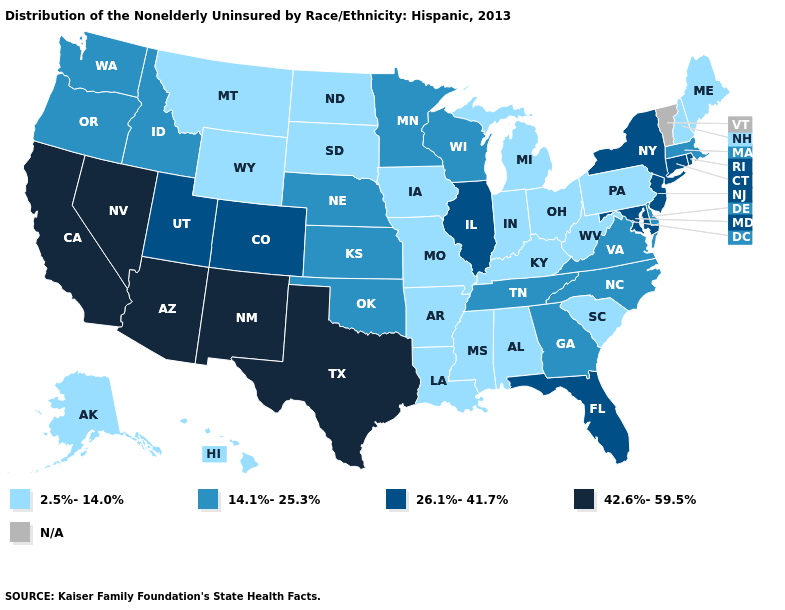What is the highest value in states that border South Dakota?
Concise answer only. 14.1%-25.3%. Does the first symbol in the legend represent the smallest category?
Short answer required. Yes. What is the value of Massachusetts?
Concise answer only. 14.1%-25.3%. Among the states that border Missouri , which have the highest value?
Concise answer only. Illinois. What is the value of Nebraska?
Short answer required. 14.1%-25.3%. Name the states that have a value in the range 14.1%-25.3%?
Quick response, please. Delaware, Georgia, Idaho, Kansas, Massachusetts, Minnesota, Nebraska, North Carolina, Oklahoma, Oregon, Tennessee, Virginia, Washington, Wisconsin. What is the value of Minnesota?
Keep it brief. 14.1%-25.3%. Does Arkansas have the highest value in the South?
Answer briefly. No. Name the states that have a value in the range N/A?
Keep it brief. Vermont. Name the states that have a value in the range 2.5%-14.0%?
Concise answer only. Alabama, Alaska, Arkansas, Hawaii, Indiana, Iowa, Kentucky, Louisiana, Maine, Michigan, Mississippi, Missouri, Montana, New Hampshire, North Dakota, Ohio, Pennsylvania, South Carolina, South Dakota, West Virginia, Wyoming. Among the states that border Vermont , which have the highest value?
Answer briefly. New York. Name the states that have a value in the range 2.5%-14.0%?
Quick response, please. Alabama, Alaska, Arkansas, Hawaii, Indiana, Iowa, Kentucky, Louisiana, Maine, Michigan, Mississippi, Missouri, Montana, New Hampshire, North Dakota, Ohio, Pennsylvania, South Carolina, South Dakota, West Virginia, Wyoming. Which states hav the highest value in the South?
Keep it brief. Texas. Name the states that have a value in the range N/A?
Write a very short answer. Vermont. Which states have the lowest value in the USA?
Short answer required. Alabama, Alaska, Arkansas, Hawaii, Indiana, Iowa, Kentucky, Louisiana, Maine, Michigan, Mississippi, Missouri, Montana, New Hampshire, North Dakota, Ohio, Pennsylvania, South Carolina, South Dakota, West Virginia, Wyoming. 